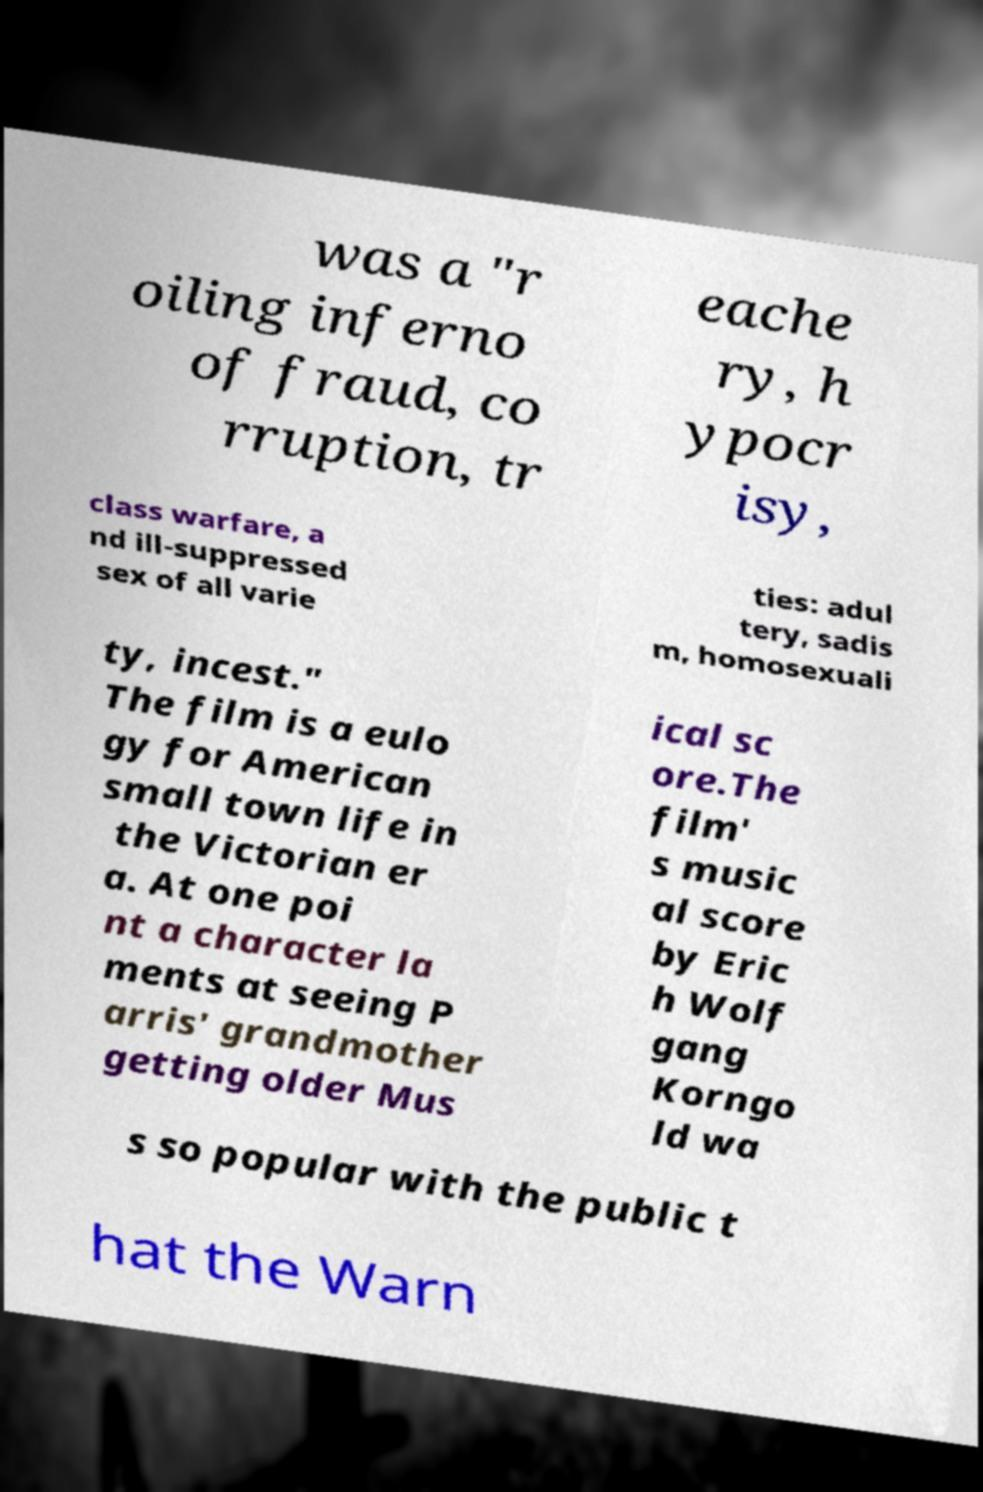Can you accurately transcribe the text from the provided image for me? was a "r oiling inferno of fraud, co rruption, tr eache ry, h ypocr isy, class warfare, a nd ill-suppressed sex of all varie ties: adul tery, sadis m, homosexuali ty, incest." The film is a eulo gy for American small town life in the Victorian er a. At one poi nt a character la ments at seeing P arris' grandmother getting older Mus ical sc ore.The film' s music al score by Eric h Wolf gang Korngo ld wa s so popular with the public t hat the Warn 